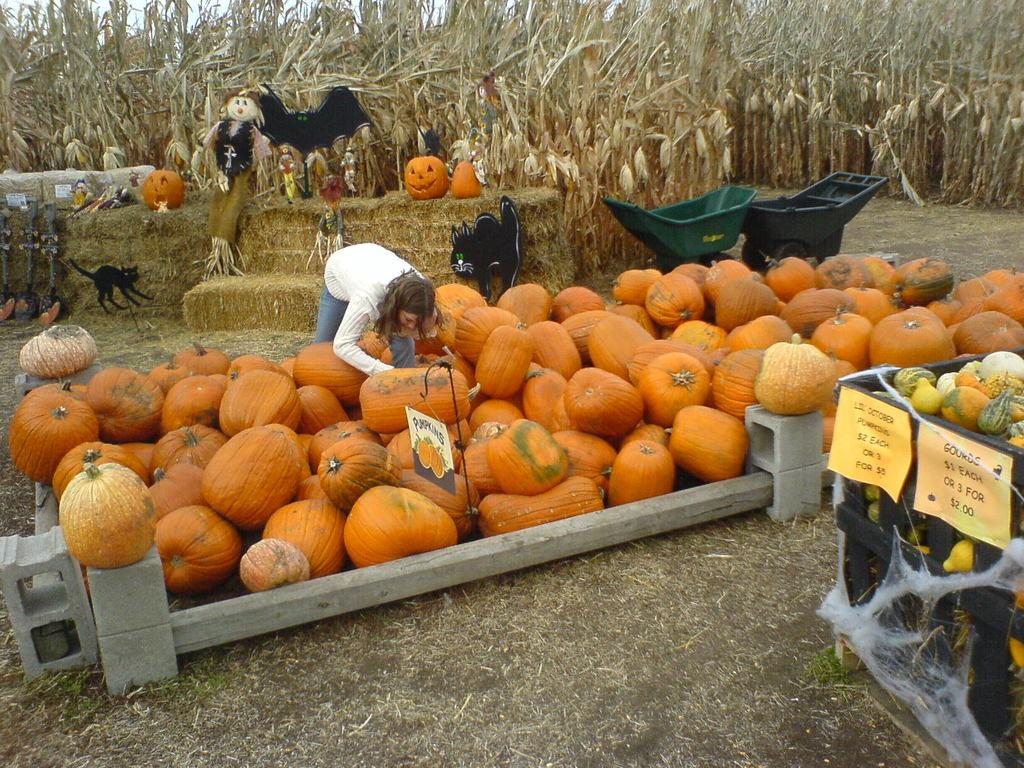What type of produce can be seen on the ground in the image? There are pumpkins on the ground in the image. What other type of produce is present in the image? There are other fruits in a box in the image. What type of transportation is visible in the image? There are carts visible in the image. What type of vegetation is present in the image? There are plants in the image. Can you describe any other objects in the image? There are other unspecified objects in the image. Is there a carpenter guiding the pumpkins in the image? There is no carpenter present in the image, nor is there any indication that the pumpkins are being guided. 